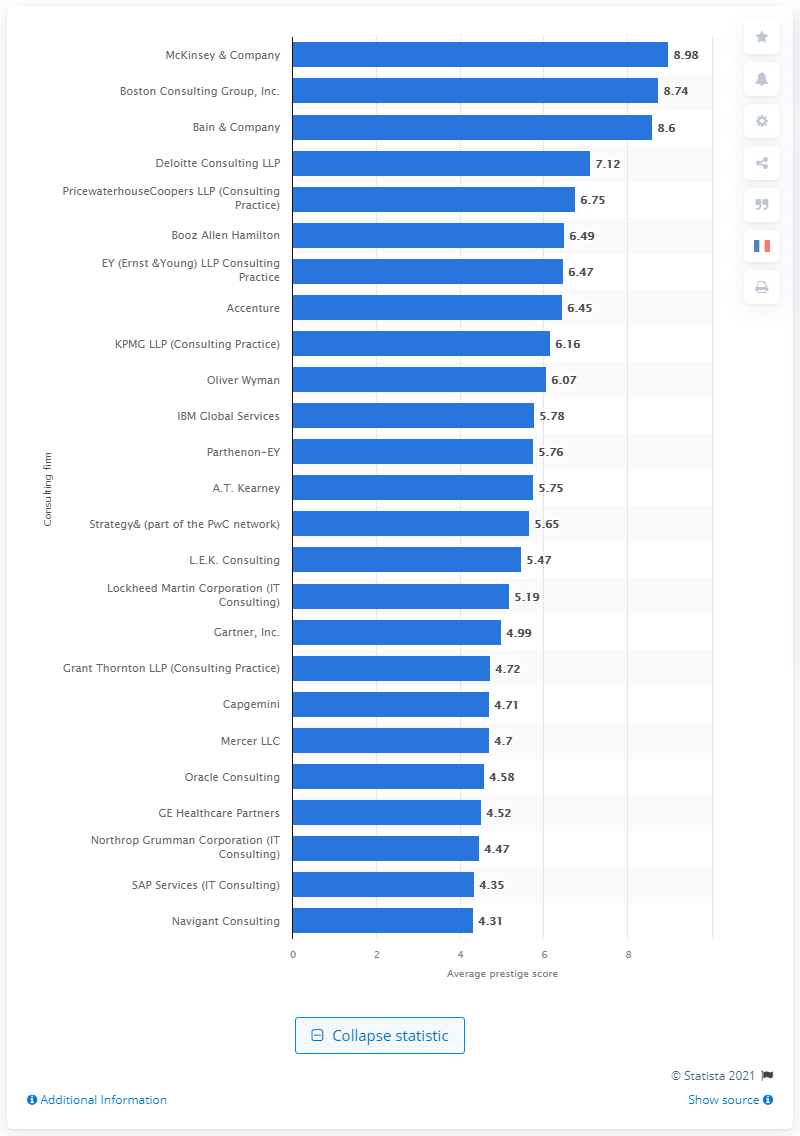Identify some key points in this picture. According to the rating, McKinsey & Company was the most prestigious consulting firm in the US in 2020, with a score of 8.98. In 2020, McKinsey & Company was the most prestigious consulting firm in the United States. 